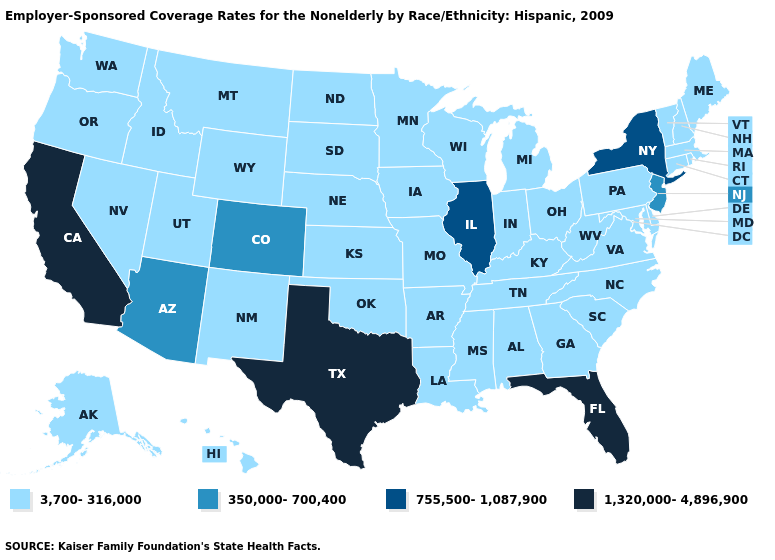Name the states that have a value in the range 1,320,000-4,896,900?
Answer briefly. California, Florida, Texas. What is the highest value in the South ?
Write a very short answer. 1,320,000-4,896,900. What is the value of Iowa?
Give a very brief answer. 3,700-316,000. What is the lowest value in states that border West Virginia?
Give a very brief answer. 3,700-316,000. Name the states that have a value in the range 1,320,000-4,896,900?
Write a very short answer. California, Florida, Texas. How many symbols are there in the legend?
Concise answer only. 4. Is the legend a continuous bar?
Quick response, please. No. Name the states that have a value in the range 1,320,000-4,896,900?
Keep it brief. California, Florida, Texas. Name the states that have a value in the range 3,700-316,000?
Concise answer only. Alabama, Alaska, Arkansas, Connecticut, Delaware, Georgia, Hawaii, Idaho, Indiana, Iowa, Kansas, Kentucky, Louisiana, Maine, Maryland, Massachusetts, Michigan, Minnesota, Mississippi, Missouri, Montana, Nebraska, Nevada, New Hampshire, New Mexico, North Carolina, North Dakota, Ohio, Oklahoma, Oregon, Pennsylvania, Rhode Island, South Carolina, South Dakota, Tennessee, Utah, Vermont, Virginia, Washington, West Virginia, Wisconsin, Wyoming. What is the lowest value in the USA?
Give a very brief answer. 3,700-316,000. Does Alaska have the highest value in the USA?
Give a very brief answer. No. What is the lowest value in the West?
Write a very short answer. 3,700-316,000. What is the value of Ohio?
Give a very brief answer. 3,700-316,000. Does Pennsylvania have the highest value in the Northeast?
Short answer required. No. What is the value of New York?
Quick response, please. 755,500-1,087,900. 